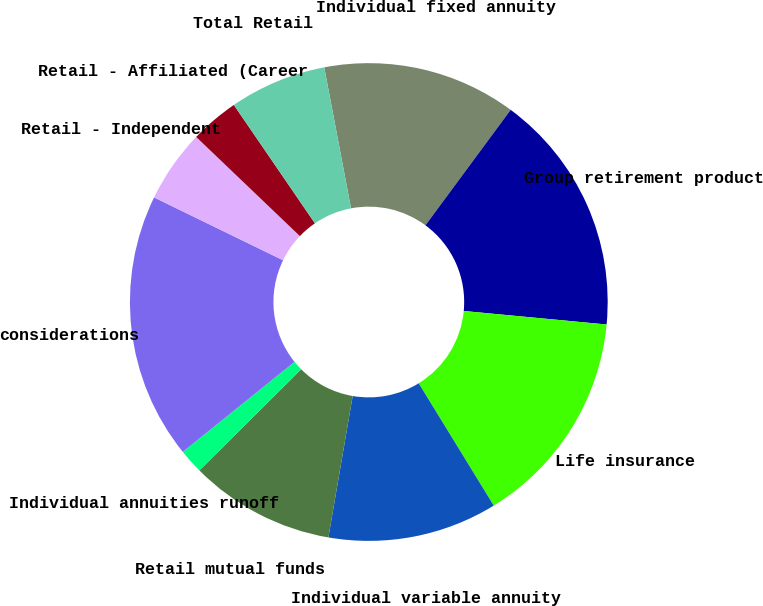<chart> <loc_0><loc_0><loc_500><loc_500><pie_chart><fcel>Individual fixed annuity<fcel>Group retirement product<fcel>Life insurance<fcel>Individual variable annuity<fcel>Retail mutual funds<fcel>Individual annuities runoff<fcel>considerations<fcel>Retail - Independent<fcel>Retail - Affiliated (Career<fcel>Total Retail<nl><fcel>13.11%<fcel>16.38%<fcel>14.74%<fcel>11.47%<fcel>9.84%<fcel>1.66%<fcel>18.01%<fcel>4.93%<fcel>3.3%<fcel>6.57%<nl></chart> 